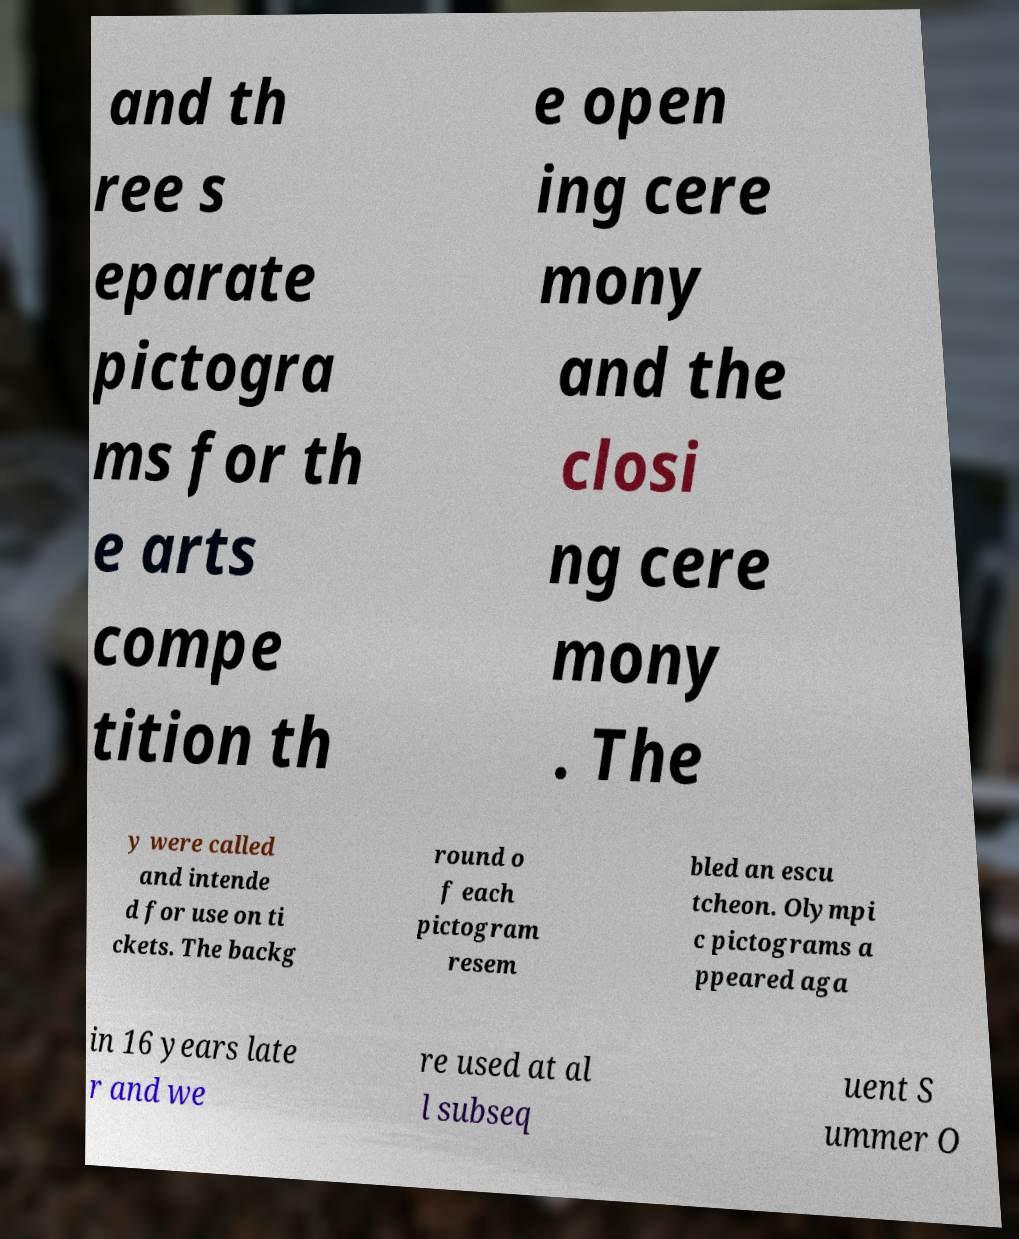Can you read and provide the text displayed in the image?This photo seems to have some interesting text. Can you extract and type it out for me? and th ree s eparate pictogra ms for th e arts compe tition th e open ing cere mony and the closi ng cere mony . The y were called and intende d for use on ti ckets. The backg round o f each pictogram resem bled an escu tcheon. Olympi c pictograms a ppeared aga in 16 years late r and we re used at al l subseq uent S ummer O 